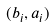Convert formula to latex. <formula><loc_0><loc_0><loc_500><loc_500>( b _ { i } , a _ { i } )</formula> 